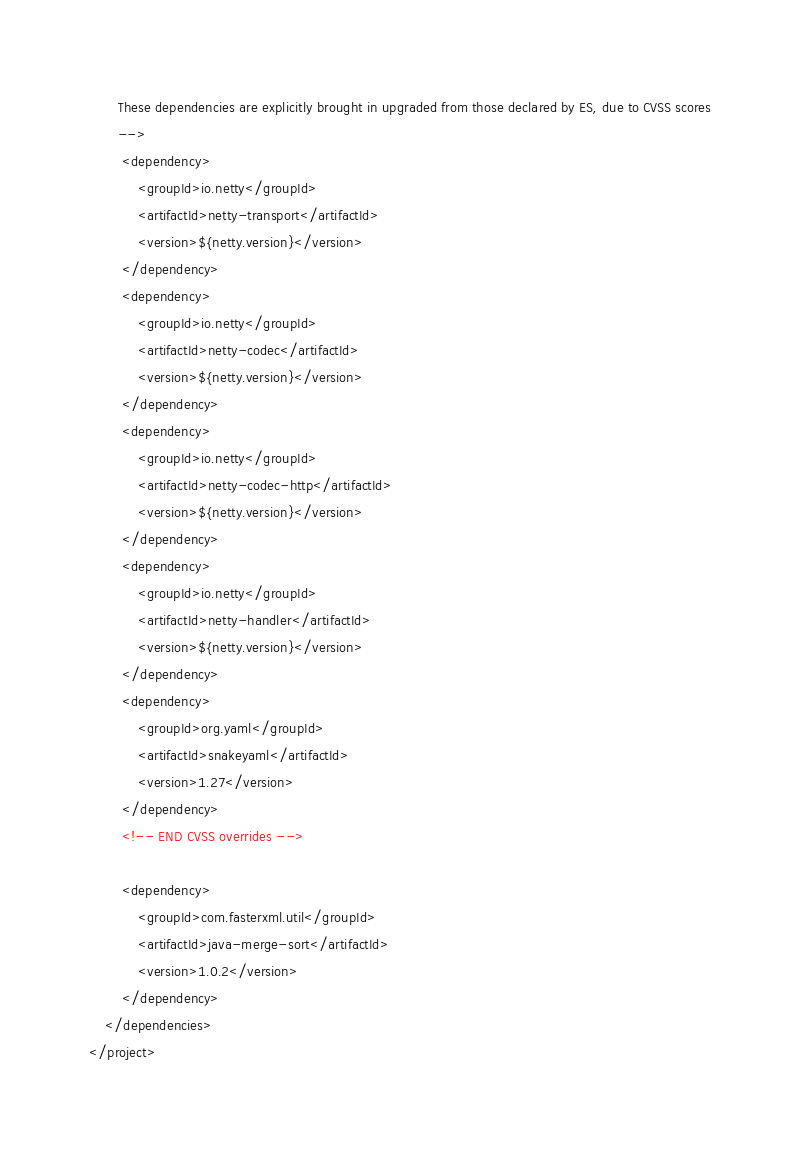<code> <loc_0><loc_0><loc_500><loc_500><_XML_>       These dependencies are explicitly brought in upgraded from those declared by ES, due to CVSS scores
       -->
        <dependency>
            <groupId>io.netty</groupId>
            <artifactId>netty-transport</artifactId>
            <version>${netty.version}</version>
        </dependency>
        <dependency>
            <groupId>io.netty</groupId>
            <artifactId>netty-codec</artifactId>
            <version>${netty.version}</version>
        </dependency>
        <dependency>
            <groupId>io.netty</groupId>
            <artifactId>netty-codec-http</artifactId>
            <version>${netty.version}</version>
        </dependency>
        <dependency>
            <groupId>io.netty</groupId>
            <artifactId>netty-handler</artifactId>
            <version>${netty.version}</version>
        </dependency>
        <dependency>
            <groupId>org.yaml</groupId>
            <artifactId>snakeyaml</artifactId>
            <version>1.27</version>
        </dependency>
        <!-- END CVSS overrides -->

        <dependency>
            <groupId>com.fasterxml.util</groupId>
            <artifactId>java-merge-sort</artifactId>
            <version>1.0.2</version>
        </dependency>
    </dependencies>
</project></code> 